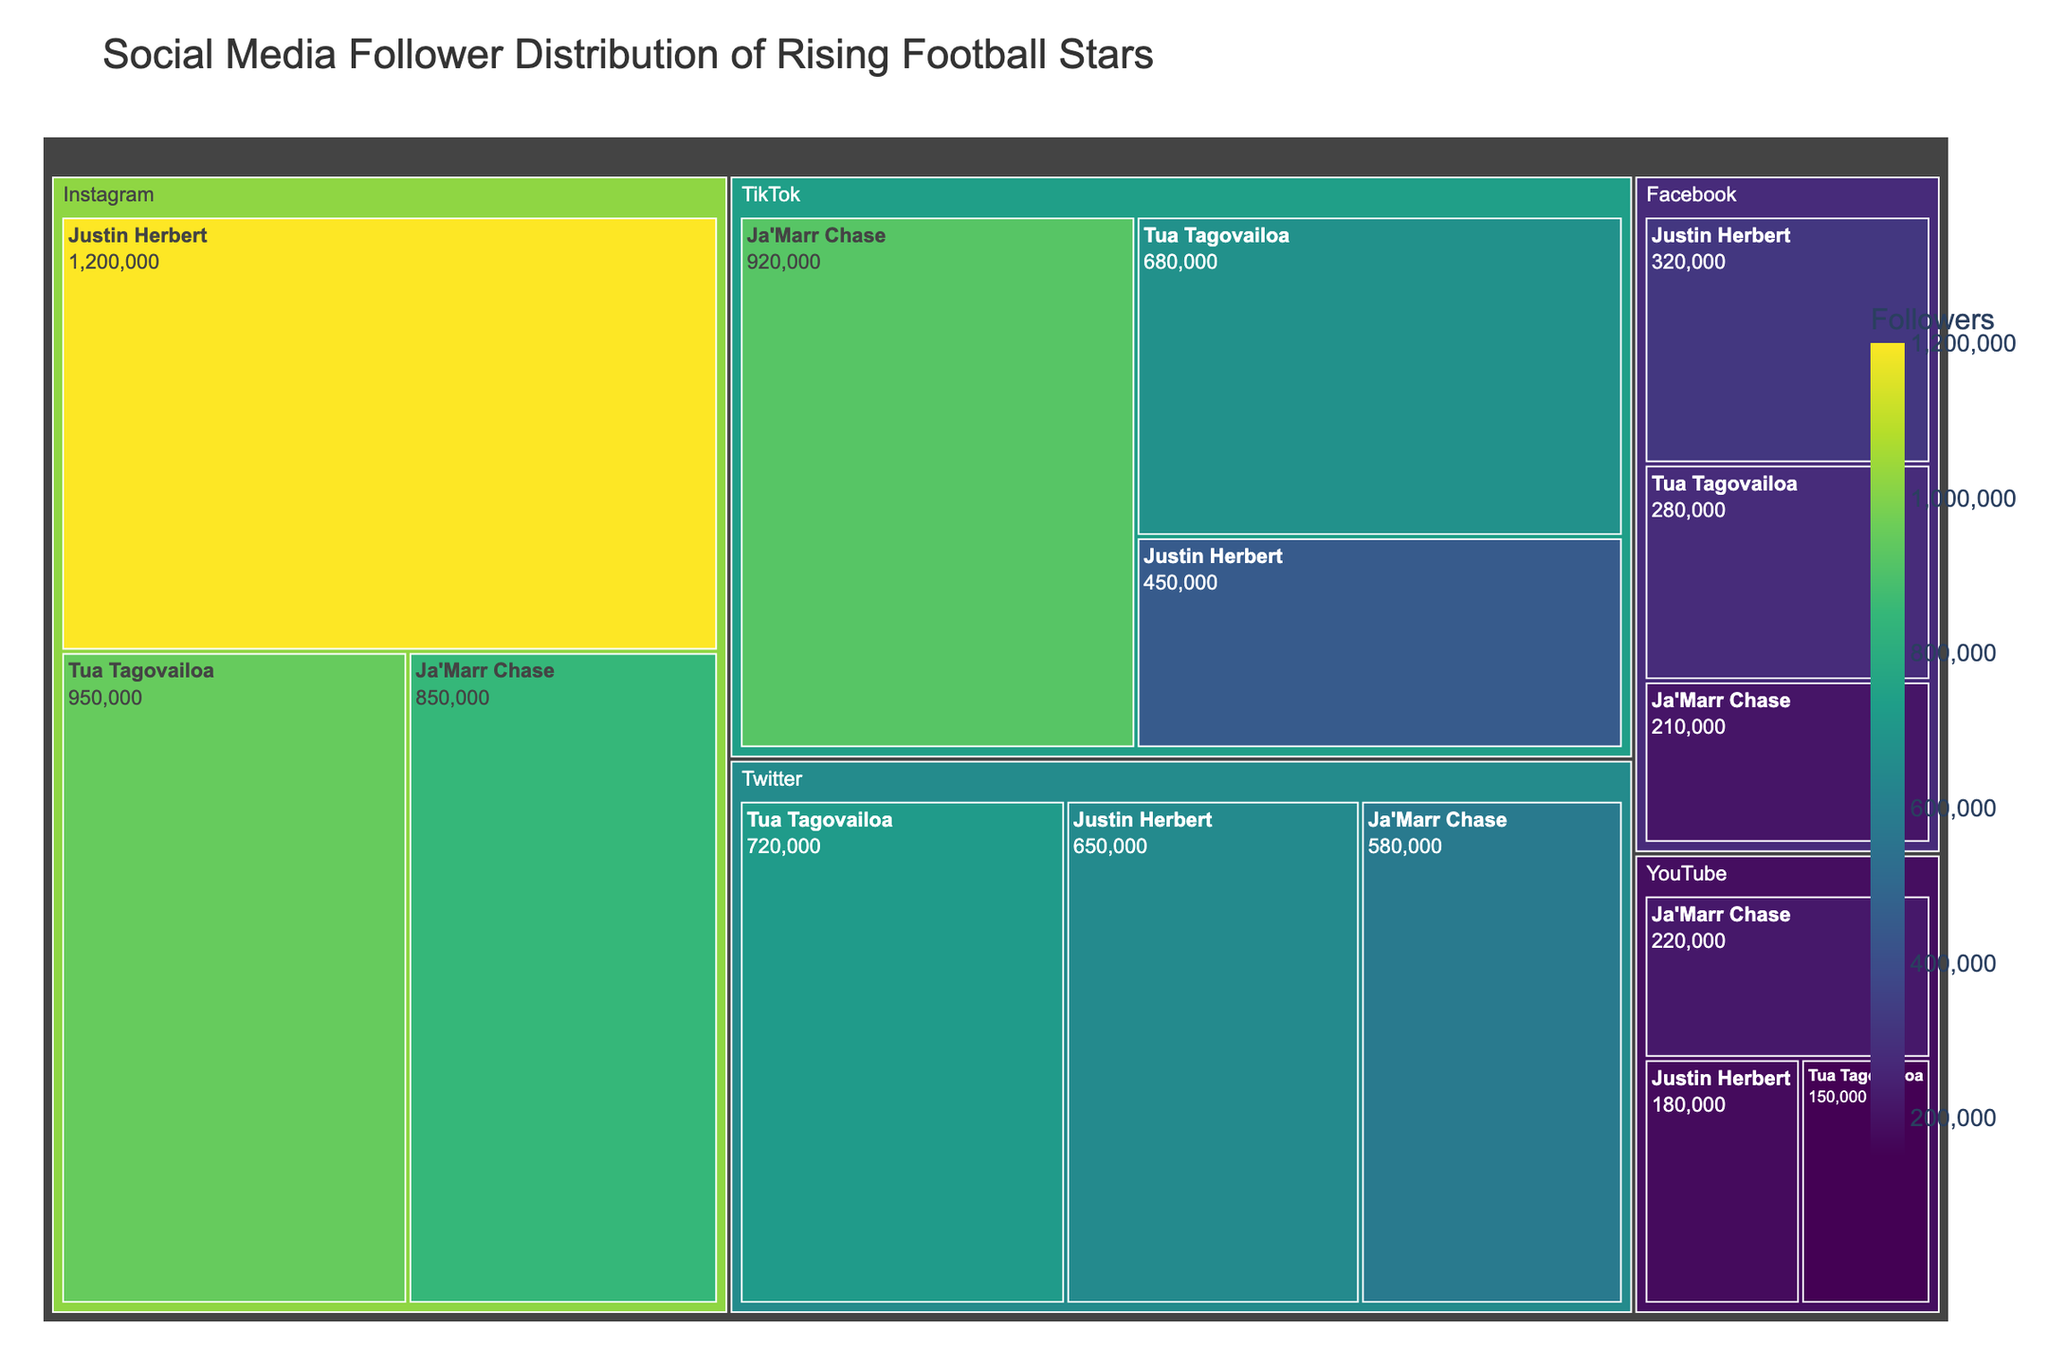What's the title of the Treemap? The title is located at the top of the figure, usually written in a larger font for emphasis.
Answer: "Social Media Follower Distribution of Rising Football Stars" Which player has the highest number of followers on TikTok? Look at the TikTok section of the Treemap and find the player with the largest area and the highest number displayed.
Answer: Ja'Marr Chase What is the total number of followers for Justin Herbert across all platforms? Sum the follower counts for Justin Herbert on Instagram, Twitter, TikTok, Facebook, and YouTube (1,200,000 + 650,000 + 450,000 + 320,000 + 180,000).
Answer: 2,800,000 Who has more Twitter followers, Tua Tagovailoa or Ja'Marr Chase? Compare the follower count for Tua Tagovailoa and Ja'Marr Chase in the Twitter section of the Treemap.
Answer: Tua Tagovailoa Which platform has the highest number of followers for all players combined? Sum the followers for all players on each platform: Instagram (1,200,000 + 950,000 + 850,000), Twitter (650,000 + 720,000 + 580,000), TikTok (450,000 + 680,000 + 920,000), Facebook (320,000 + 280,000 + 210,000), YouTube (180,000 + 150,000 + 220,000). Compare the sums to find the highest.
Answer: Instagram What is the most common color in the Treemap, and what does it indicate? Identify the predominant color on the Treemap, which is assigned based on the number of followers. More saturated colors indicate higher follower counts.
Answer: Dark green, indicating higher numbers of followers Which player has the smallest number of followers on Facebook? Check the Facebook section of the Treemap to find the player with the smallest area and the lowest number displayed.
Answer: Ja'Marr Chase What is the average number of followers for Tua Tagovailoa across all platforms? Sum Tua Tagovailoa's followers on each platform (950,000 + 720,000 + 680,000 + 280,000 + 150,000) and divide by the number of platforms (5).
Answer: 556,000 Between Instagram and YouTube, which platform has a smaller maximum follower count for a single player? Compare the highest follower count for any player on Instagram with the highest on YouTube.
Answer: YouTube Which platform does Ja'Marr Chase have the highest follower count on? Look at the Treemap sections for Ja'Marr Chase across each platform and identify the one with the highest follower count.
Answer: TikTok 